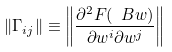<formula> <loc_0><loc_0><loc_500><loc_500>\| \Gamma _ { i j } \| \equiv \left \| \frac { \partial ^ { 2 } F ( \ B w ) } { \partial w ^ { i } \partial w ^ { j } } \right \|</formula> 